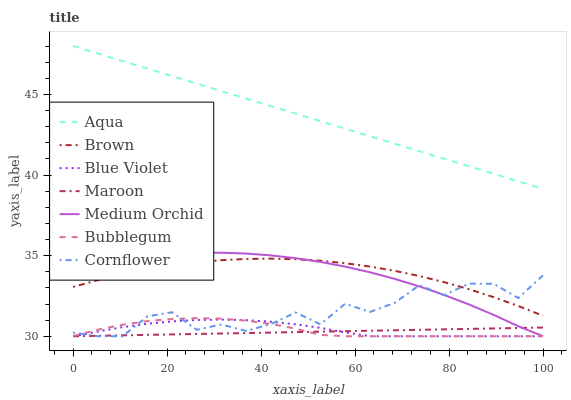Does Maroon have the minimum area under the curve?
Answer yes or no. Yes. Does Aqua have the maximum area under the curve?
Answer yes or no. Yes. Does Cornflower have the minimum area under the curve?
Answer yes or no. No. Does Cornflower have the maximum area under the curve?
Answer yes or no. No. Is Maroon the smoothest?
Answer yes or no. Yes. Is Cornflower the roughest?
Answer yes or no. Yes. Is Medium Orchid the smoothest?
Answer yes or no. No. Is Medium Orchid the roughest?
Answer yes or no. No. Does Cornflower have the lowest value?
Answer yes or no. Yes. Does Aqua have the lowest value?
Answer yes or no. No. Does Aqua have the highest value?
Answer yes or no. Yes. Does Cornflower have the highest value?
Answer yes or no. No. Is Blue Violet less than Brown?
Answer yes or no. Yes. Is Aqua greater than Cornflower?
Answer yes or no. Yes. Does Brown intersect Medium Orchid?
Answer yes or no. Yes. Is Brown less than Medium Orchid?
Answer yes or no. No. Is Brown greater than Medium Orchid?
Answer yes or no. No. Does Blue Violet intersect Brown?
Answer yes or no. No. 